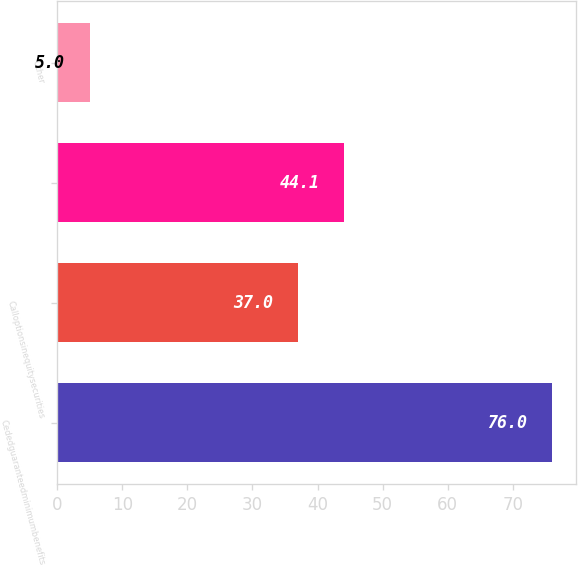<chart> <loc_0><loc_0><loc_500><loc_500><bar_chart><fcel>Cededguaranteedminimumbenefits<fcel>Calloptionsinequitysecurities<fcel>Unnamed: 2<fcel>Other<nl><fcel>76<fcel>37<fcel>44.1<fcel>5<nl></chart> 